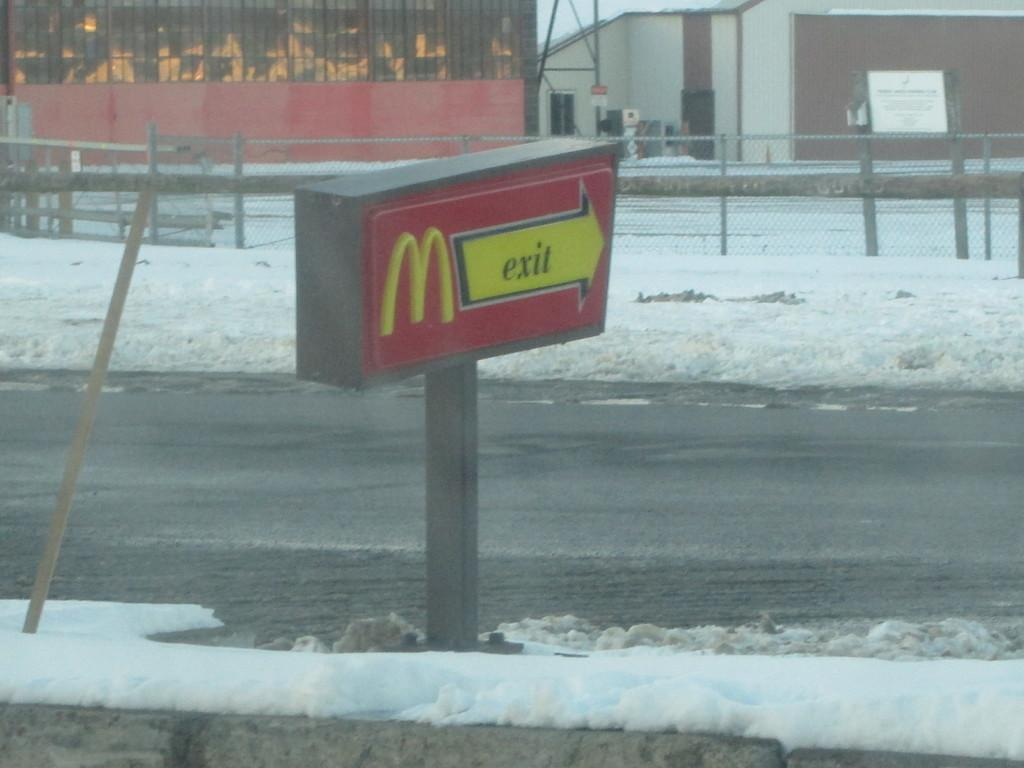<image>
Provide a brief description of the given image. A arrow points to the exit of a McDonalds restaurant. 